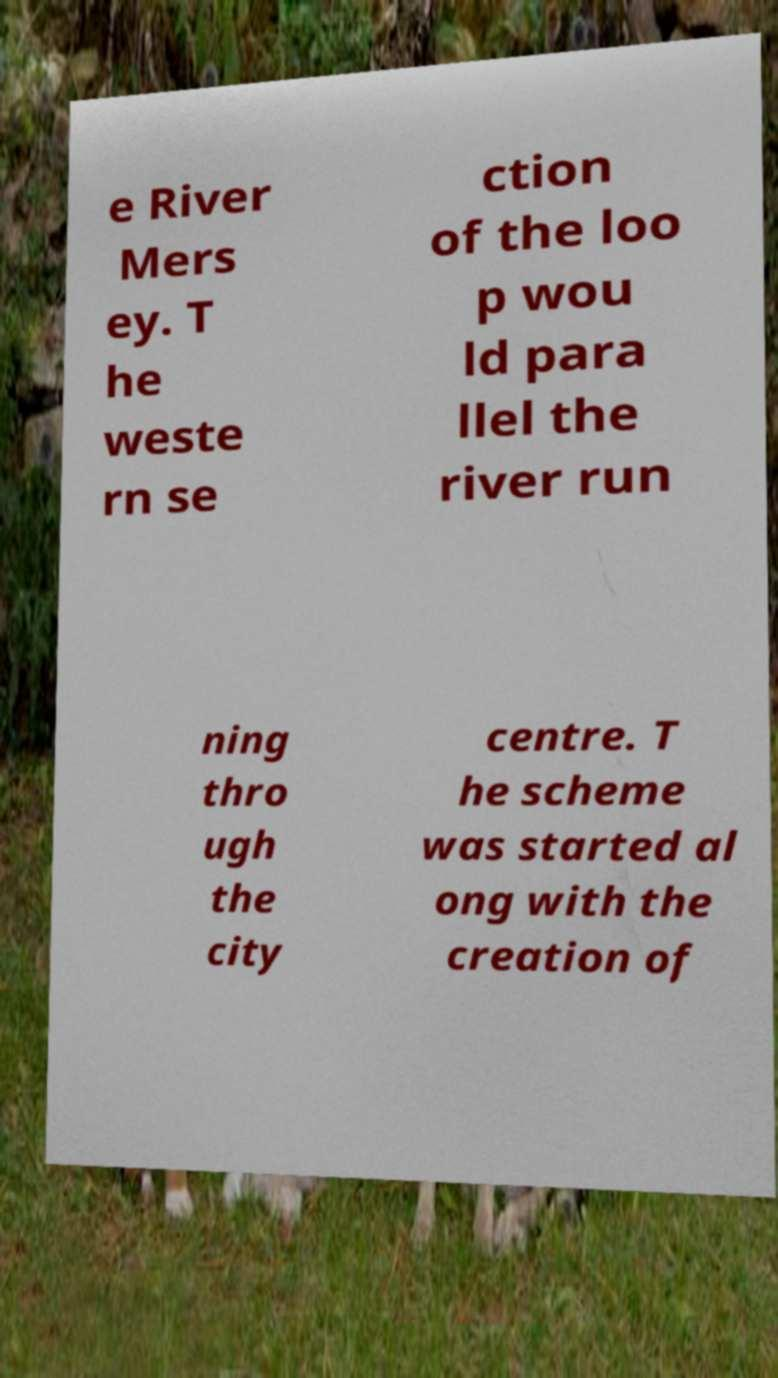For documentation purposes, I need the text within this image transcribed. Could you provide that? e River Mers ey. T he weste rn se ction of the loo p wou ld para llel the river run ning thro ugh the city centre. T he scheme was started al ong with the creation of 